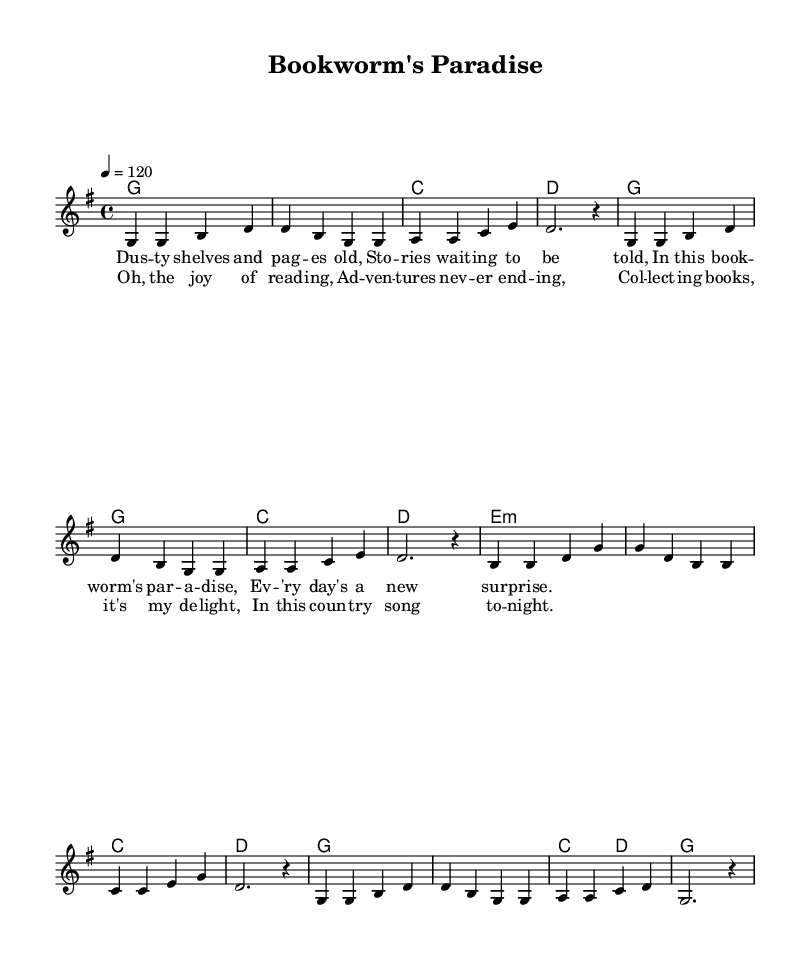What is the key signature of this music? The key signature shows one sharp in the staff, which indicates G major. This means that the note F# is played instead of F natural.
Answer: G major What is the time signature of this piece? The time signature is indicated at the beginning of the piece as 4/4, which means there are four beats in a measure and the quarter note gets one beat.
Answer: 4/4 What is the tempo marking for this piece? The tempo marking is set at "4 = 120," which means there are 120 quarter note beats per minute, indicating a brisk pace for the performance.
Answer: 120 How many measures are in the melody section? Counting the melody sections, there are eight measures total. Each measure is separated by vertical lines in the music notation.
Answer: 8 What chord does the piece start with? The piece starts with a G major chord, which is noted at the beginning in the harmonies section. This chord is shown at the start of the score.
Answer: G What is the main theme of the lyrics in this song? The lyrics depict themes of reading and book collecting, celebrating the joy of stories and discoveries found within books. This is suggested in the lyrics provided alongside the score.
Answer: Reading and book collecting 